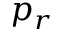Convert formula to latex. <formula><loc_0><loc_0><loc_500><loc_500>p _ { r }</formula> 